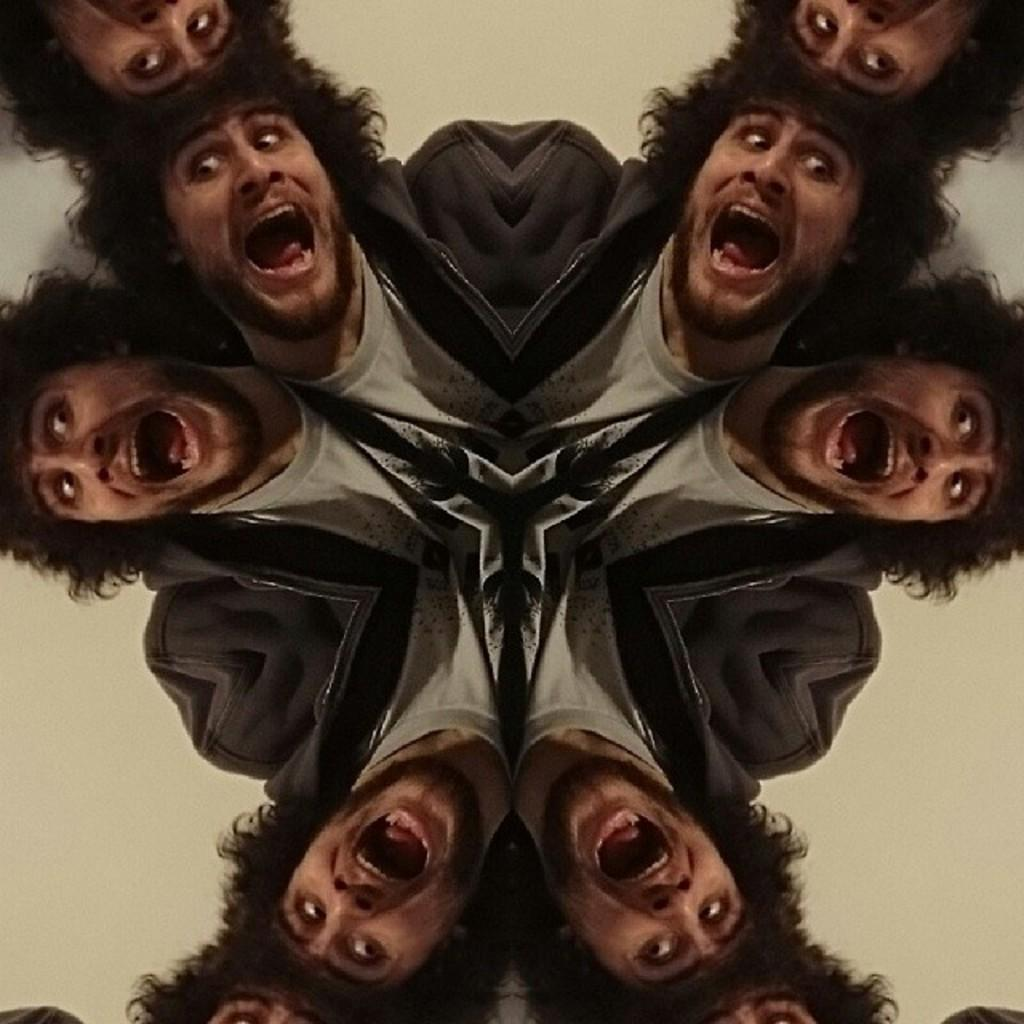What can be observed about the nature of the image? The image is edited. What is the main subject of the image? There is a man in the image. How is the man depicted in the image? The man is shown in different angles. What type of teeth can be seen in the image? There are no teeth visible in the image, as it features a man in different angles and does not show any close-up of his teeth. What type of competition is the man participating in the image? There is no indication in the image that the man is participating in any competition. 